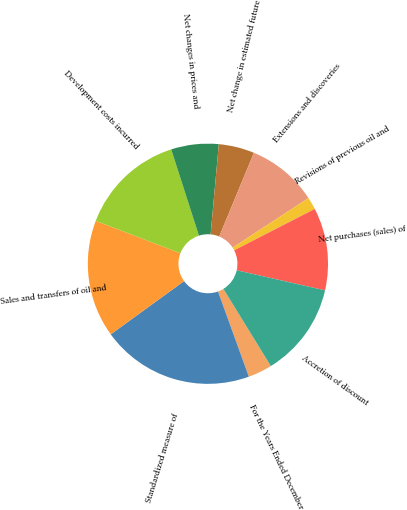<chart> <loc_0><loc_0><loc_500><loc_500><pie_chart><fcel>For the Years Ended December<fcel>Standardized measure of<fcel>Sales and transfers of oil and<fcel>Development costs incurred<fcel>Net changes in prices and<fcel>Net change in estimated future<fcel>Extensions and discoveries<fcel>Revisions of previous oil and<fcel>Net purchases (sales) of<fcel>Accretion of discount<nl><fcel>3.24%<fcel>20.53%<fcel>15.81%<fcel>14.24%<fcel>6.39%<fcel>4.81%<fcel>9.53%<fcel>1.67%<fcel>11.1%<fcel>12.67%<nl></chart> 